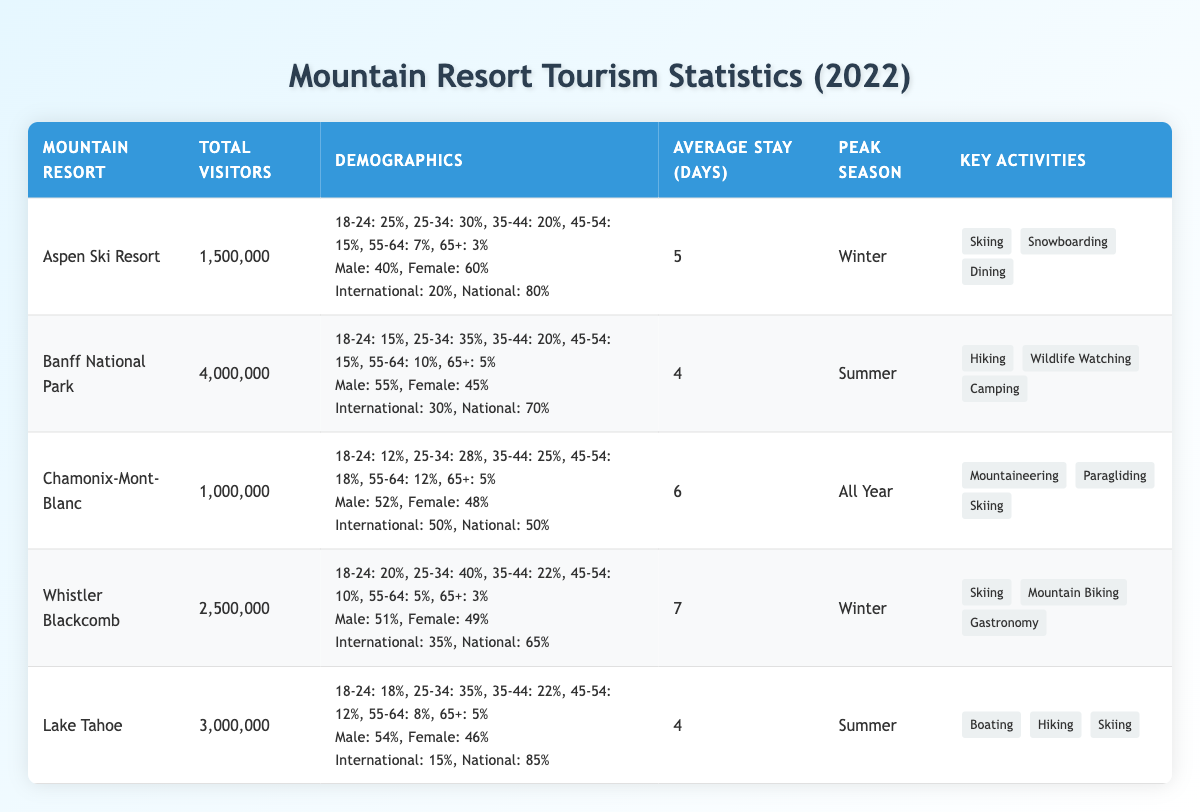What mountain resort had the highest total visitors in 2022? By comparing the "Total Visitors" column for each mountain resort, Banff National Park has the highest total at 4,000,000 visitors.
Answer: Banff National Park What percentage of visitors to Aspen Ski Resort were male? The table states that 40% of the visitors to Aspen Ski Resort were male.
Answer: 40% What is the average stay length for visitors at Chamonix-Mont-Blanc? The table shows that the "Average Stay Length (Days)" for Chamonix-Mont-Blanc is 6 days.
Answer: 6 days How many visitors did Lake Tahoe receive in 2022? According to the table, Lake Tahoe received 3,000,000 visitors in 2022.
Answer: 3,000,000 Which mountain resort has a peak season in summer and what are its key activities? The table indicates that Banff National Park has a peak season in summer, and its key activities include Hiking, Wildlife Watching, and Camping.
Answer: Banff National Park; Hiking, Wildlife Watching, Camping What is the combined total of visitors to Whistler Blackcomb and Chamonix-Mont-Blanc? The total visitors for Whistler Blackcomb is 2,500,000 and for Chamonix-Mont-Blanc is 1,000,000. Adding these yields 3,500,000 visitors.
Answer: 3,500,000 Are there more visitors to Aspen Ski Resort or Chamonix-Mont-Blanc? Aspen Ski Resort had 1,500,000 visitors while Chamonix-Mont-Blanc had 1,000,000. Since 1,500,000 is greater than 1,000,000, Aspen Ski Resort had more visitors.
Answer: Yes, Aspen Ski Resort What percentage of visitors to Lake Tahoe were from international origins? The table shows that 15% of Lake Tahoe's visitors came from international origins.
Answer: 15% Which age group made up the largest percentage of visitors to Whistler Blackcomb? The table indicates that the largest age group at Whistler Blackcomb is 25-34 years, making up 40% of the visitors.
Answer: 25-34 years What is the difference in average stay length between Whistler Blackcomb and Aspen Ski Resort? Whistler Blackcomb has an average stay of 7 days and Aspen Ski Resort has 5 days. The difference is 7 - 5 = 2 days.
Answer: 2 days What is the overall gender distribution (male vs female) for visitors across all listed mountain resorts? By combining the male and female percentages from each resort and averaging them, we get approximately 45.4% male and 54.6% female.
Answer: 45.4% male, 54.6% female 